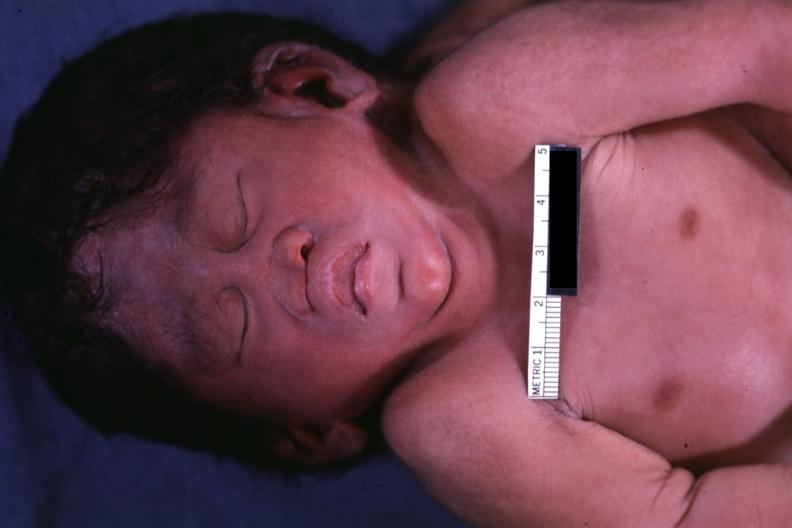what is present?
Answer the question using a single word or phrase. Conjoined twins cephalothoracopagus janiceps 